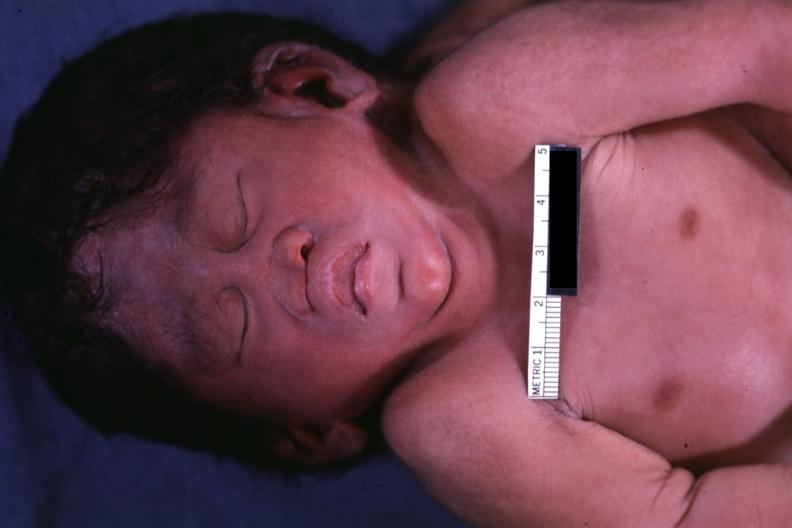what is present?
Answer the question using a single word or phrase. Conjoined twins cephalothoracopagus janiceps 